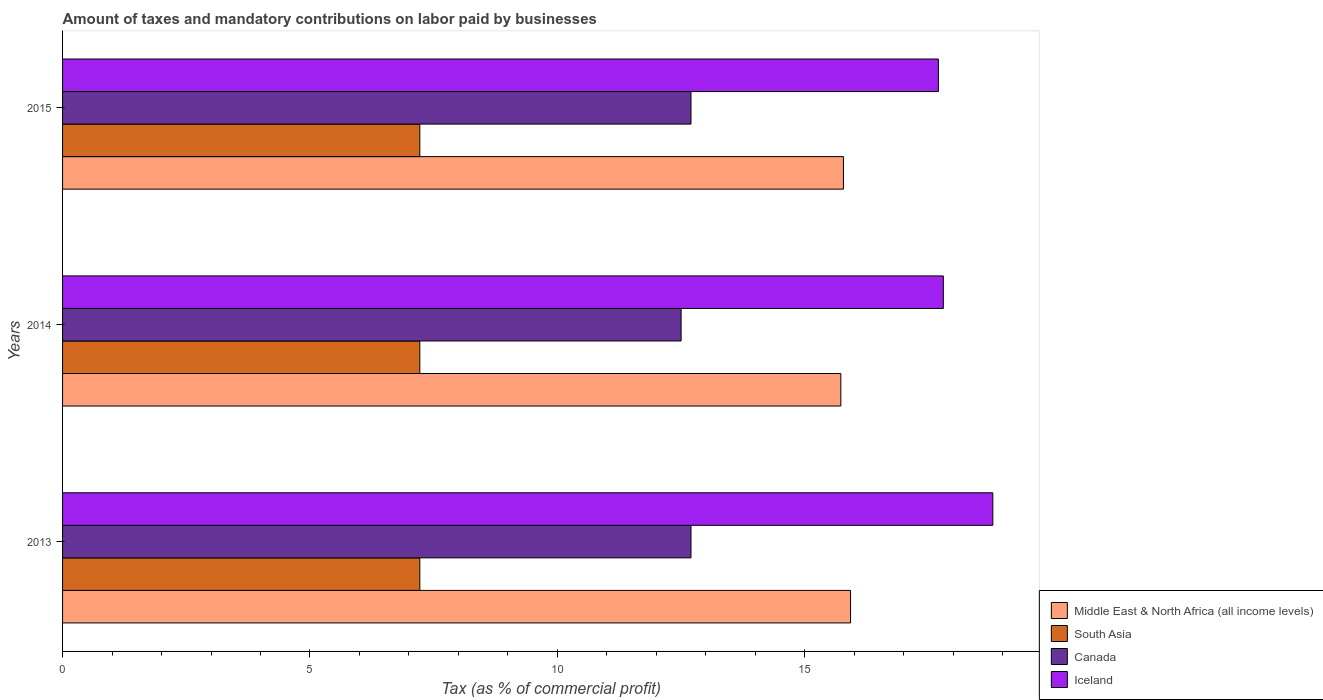How many different coloured bars are there?
Your response must be concise. 4. Are the number of bars per tick equal to the number of legend labels?
Offer a terse response. Yes. Are the number of bars on each tick of the Y-axis equal?
Provide a succinct answer. Yes. How many bars are there on the 3rd tick from the top?
Keep it short and to the point. 4. How many bars are there on the 3rd tick from the bottom?
Keep it short and to the point. 4. What is the label of the 3rd group of bars from the top?
Offer a very short reply. 2013. Across all years, what is the maximum percentage of taxes paid by businesses in Canada?
Offer a terse response. 12.7. In which year was the percentage of taxes paid by businesses in Canada maximum?
Provide a succinct answer. 2013. In which year was the percentage of taxes paid by businesses in South Asia minimum?
Provide a succinct answer. 2013. What is the total percentage of taxes paid by businesses in South Asia in the graph?
Ensure brevity in your answer.  21.66. What is the difference between the percentage of taxes paid by businesses in Iceland in 2013 and that in 2015?
Ensure brevity in your answer.  1.1. What is the difference between the percentage of taxes paid by businesses in Middle East & North Africa (all income levels) in 2014 and the percentage of taxes paid by businesses in Iceland in 2013?
Keep it short and to the point. -3.07. What is the average percentage of taxes paid by businesses in Iceland per year?
Your response must be concise. 18.1. In the year 2013, what is the difference between the percentage of taxes paid by businesses in Middle East & North Africa (all income levels) and percentage of taxes paid by businesses in Iceland?
Offer a terse response. -2.88. In how many years, is the percentage of taxes paid by businesses in Canada greater than 10 %?
Offer a terse response. 3. What is the ratio of the percentage of taxes paid by businesses in South Asia in 2013 to that in 2015?
Make the answer very short. 1. Is the percentage of taxes paid by businesses in Iceland in 2013 less than that in 2015?
Your answer should be very brief. No. What is the difference between the highest and the lowest percentage of taxes paid by businesses in Canada?
Your answer should be compact. 0.2. In how many years, is the percentage of taxes paid by businesses in South Asia greater than the average percentage of taxes paid by businesses in South Asia taken over all years?
Keep it short and to the point. 0. Is the sum of the percentage of taxes paid by businesses in Canada in 2014 and 2015 greater than the maximum percentage of taxes paid by businesses in Middle East & North Africa (all income levels) across all years?
Your answer should be very brief. Yes. What does the 4th bar from the top in 2015 represents?
Provide a short and direct response. Middle East & North Africa (all income levels). What does the 1st bar from the bottom in 2014 represents?
Ensure brevity in your answer.  Middle East & North Africa (all income levels). How many years are there in the graph?
Ensure brevity in your answer.  3. Where does the legend appear in the graph?
Provide a succinct answer. Bottom right. How many legend labels are there?
Your answer should be compact. 4. What is the title of the graph?
Provide a short and direct response. Amount of taxes and mandatory contributions on labor paid by businesses. What is the label or title of the X-axis?
Ensure brevity in your answer.  Tax (as % of commercial profit). What is the Tax (as % of commercial profit) of Middle East & North Africa (all income levels) in 2013?
Provide a succinct answer. 15.93. What is the Tax (as % of commercial profit) of South Asia in 2013?
Make the answer very short. 7.22. What is the Tax (as % of commercial profit) of Middle East & North Africa (all income levels) in 2014?
Keep it short and to the point. 15.73. What is the Tax (as % of commercial profit) of South Asia in 2014?
Provide a succinct answer. 7.22. What is the Tax (as % of commercial profit) of Canada in 2014?
Make the answer very short. 12.5. What is the Tax (as % of commercial profit) in Middle East & North Africa (all income levels) in 2015?
Your answer should be very brief. 15.78. What is the Tax (as % of commercial profit) in South Asia in 2015?
Offer a very short reply. 7.22. What is the Tax (as % of commercial profit) in Canada in 2015?
Keep it short and to the point. 12.7. What is the Tax (as % of commercial profit) in Iceland in 2015?
Your response must be concise. 17.7. Across all years, what is the maximum Tax (as % of commercial profit) of Middle East & North Africa (all income levels)?
Provide a short and direct response. 15.93. Across all years, what is the maximum Tax (as % of commercial profit) in South Asia?
Offer a terse response. 7.22. Across all years, what is the minimum Tax (as % of commercial profit) of Middle East & North Africa (all income levels)?
Give a very brief answer. 15.73. Across all years, what is the minimum Tax (as % of commercial profit) of South Asia?
Your response must be concise. 7.22. Across all years, what is the minimum Tax (as % of commercial profit) in Canada?
Provide a succinct answer. 12.5. Across all years, what is the minimum Tax (as % of commercial profit) of Iceland?
Your answer should be compact. 17.7. What is the total Tax (as % of commercial profit) in Middle East & North Africa (all income levels) in the graph?
Offer a terse response. 47.43. What is the total Tax (as % of commercial profit) of South Asia in the graph?
Offer a very short reply. 21.66. What is the total Tax (as % of commercial profit) of Canada in the graph?
Your answer should be very brief. 37.9. What is the total Tax (as % of commercial profit) of Iceland in the graph?
Your answer should be very brief. 54.3. What is the difference between the Tax (as % of commercial profit) in Middle East & North Africa (all income levels) in 2013 and that in 2014?
Give a very brief answer. 0.2. What is the difference between the Tax (as % of commercial profit) in Middle East & North Africa (all income levels) in 2013 and that in 2015?
Provide a short and direct response. 0.14. What is the difference between the Tax (as % of commercial profit) of Canada in 2013 and that in 2015?
Offer a terse response. 0. What is the difference between the Tax (as % of commercial profit) in Middle East & North Africa (all income levels) in 2014 and that in 2015?
Your response must be concise. -0.05. What is the difference between the Tax (as % of commercial profit) in Canada in 2014 and that in 2015?
Make the answer very short. -0.2. What is the difference between the Tax (as % of commercial profit) of Iceland in 2014 and that in 2015?
Offer a very short reply. 0.1. What is the difference between the Tax (as % of commercial profit) of Middle East & North Africa (all income levels) in 2013 and the Tax (as % of commercial profit) of South Asia in 2014?
Your answer should be very brief. 8.71. What is the difference between the Tax (as % of commercial profit) in Middle East & North Africa (all income levels) in 2013 and the Tax (as % of commercial profit) in Canada in 2014?
Your answer should be very brief. 3.42. What is the difference between the Tax (as % of commercial profit) in Middle East & North Africa (all income levels) in 2013 and the Tax (as % of commercial profit) in Iceland in 2014?
Give a very brief answer. -1.88. What is the difference between the Tax (as % of commercial profit) in South Asia in 2013 and the Tax (as % of commercial profit) in Canada in 2014?
Your answer should be very brief. -5.28. What is the difference between the Tax (as % of commercial profit) in South Asia in 2013 and the Tax (as % of commercial profit) in Iceland in 2014?
Your answer should be very brief. -10.58. What is the difference between the Tax (as % of commercial profit) in Middle East & North Africa (all income levels) in 2013 and the Tax (as % of commercial profit) in South Asia in 2015?
Provide a short and direct response. 8.71. What is the difference between the Tax (as % of commercial profit) in Middle East & North Africa (all income levels) in 2013 and the Tax (as % of commercial profit) in Canada in 2015?
Provide a succinct answer. 3.23. What is the difference between the Tax (as % of commercial profit) of Middle East & North Africa (all income levels) in 2013 and the Tax (as % of commercial profit) of Iceland in 2015?
Make the answer very short. -1.77. What is the difference between the Tax (as % of commercial profit) in South Asia in 2013 and the Tax (as % of commercial profit) in Canada in 2015?
Keep it short and to the point. -5.48. What is the difference between the Tax (as % of commercial profit) in South Asia in 2013 and the Tax (as % of commercial profit) in Iceland in 2015?
Make the answer very short. -10.48. What is the difference between the Tax (as % of commercial profit) of Middle East & North Africa (all income levels) in 2014 and the Tax (as % of commercial profit) of South Asia in 2015?
Offer a terse response. 8.51. What is the difference between the Tax (as % of commercial profit) of Middle East & North Africa (all income levels) in 2014 and the Tax (as % of commercial profit) of Canada in 2015?
Ensure brevity in your answer.  3.03. What is the difference between the Tax (as % of commercial profit) in Middle East & North Africa (all income levels) in 2014 and the Tax (as % of commercial profit) in Iceland in 2015?
Provide a short and direct response. -1.97. What is the difference between the Tax (as % of commercial profit) of South Asia in 2014 and the Tax (as % of commercial profit) of Canada in 2015?
Provide a short and direct response. -5.48. What is the difference between the Tax (as % of commercial profit) of South Asia in 2014 and the Tax (as % of commercial profit) of Iceland in 2015?
Offer a very short reply. -10.48. What is the difference between the Tax (as % of commercial profit) of Canada in 2014 and the Tax (as % of commercial profit) of Iceland in 2015?
Keep it short and to the point. -5.2. What is the average Tax (as % of commercial profit) in Middle East & North Africa (all income levels) per year?
Your answer should be compact. 15.81. What is the average Tax (as % of commercial profit) of South Asia per year?
Give a very brief answer. 7.22. What is the average Tax (as % of commercial profit) in Canada per year?
Ensure brevity in your answer.  12.63. What is the average Tax (as % of commercial profit) of Iceland per year?
Offer a terse response. 18.1. In the year 2013, what is the difference between the Tax (as % of commercial profit) of Middle East & North Africa (all income levels) and Tax (as % of commercial profit) of South Asia?
Keep it short and to the point. 8.71. In the year 2013, what is the difference between the Tax (as % of commercial profit) in Middle East & North Africa (all income levels) and Tax (as % of commercial profit) in Canada?
Offer a very short reply. 3.23. In the year 2013, what is the difference between the Tax (as % of commercial profit) of Middle East & North Africa (all income levels) and Tax (as % of commercial profit) of Iceland?
Make the answer very short. -2.88. In the year 2013, what is the difference between the Tax (as % of commercial profit) in South Asia and Tax (as % of commercial profit) in Canada?
Offer a terse response. -5.48. In the year 2013, what is the difference between the Tax (as % of commercial profit) of South Asia and Tax (as % of commercial profit) of Iceland?
Provide a short and direct response. -11.58. In the year 2013, what is the difference between the Tax (as % of commercial profit) in Canada and Tax (as % of commercial profit) in Iceland?
Offer a terse response. -6.1. In the year 2014, what is the difference between the Tax (as % of commercial profit) of Middle East & North Africa (all income levels) and Tax (as % of commercial profit) of South Asia?
Your answer should be compact. 8.51. In the year 2014, what is the difference between the Tax (as % of commercial profit) of Middle East & North Africa (all income levels) and Tax (as % of commercial profit) of Canada?
Keep it short and to the point. 3.23. In the year 2014, what is the difference between the Tax (as % of commercial profit) in Middle East & North Africa (all income levels) and Tax (as % of commercial profit) in Iceland?
Give a very brief answer. -2.07. In the year 2014, what is the difference between the Tax (as % of commercial profit) of South Asia and Tax (as % of commercial profit) of Canada?
Make the answer very short. -5.28. In the year 2014, what is the difference between the Tax (as % of commercial profit) of South Asia and Tax (as % of commercial profit) of Iceland?
Provide a short and direct response. -10.58. In the year 2014, what is the difference between the Tax (as % of commercial profit) of Canada and Tax (as % of commercial profit) of Iceland?
Your response must be concise. -5.3. In the year 2015, what is the difference between the Tax (as % of commercial profit) of Middle East & North Africa (all income levels) and Tax (as % of commercial profit) of South Asia?
Your response must be concise. 8.56. In the year 2015, what is the difference between the Tax (as % of commercial profit) in Middle East & North Africa (all income levels) and Tax (as % of commercial profit) in Canada?
Your answer should be very brief. 3.08. In the year 2015, what is the difference between the Tax (as % of commercial profit) of Middle East & North Africa (all income levels) and Tax (as % of commercial profit) of Iceland?
Give a very brief answer. -1.92. In the year 2015, what is the difference between the Tax (as % of commercial profit) in South Asia and Tax (as % of commercial profit) in Canada?
Your answer should be very brief. -5.48. In the year 2015, what is the difference between the Tax (as % of commercial profit) in South Asia and Tax (as % of commercial profit) in Iceland?
Your answer should be compact. -10.48. In the year 2015, what is the difference between the Tax (as % of commercial profit) of Canada and Tax (as % of commercial profit) of Iceland?
Provide a succinct answer. -5. What is the ratio of the Tax (as % of commercial profit) of Middle East & North Africa (all income levels) in 2013 to that in 2014?
Offer a terse response. 1.01. What is the ratio of the Tax (as % of commercial profit) in Canada in 2013 to that in 2014?
Your answer should be very brief. 1.02. What is the ratio of the Tax (as % of commercial profit) of Iceland in 2013 to that in 2014?
Ensure brevity in your answer.  1.06. What is the ratio of the Tax (as % of commercial profit) in Middle East & North Africa (all income levels) in 2013 to that in 2015?
Your response must be concise. 1.01. What is the ratio of the Tax (as % of commercial profit) of South Asia in 2013 to that in 2015?
Provide a short and direct response. 1. What is the ratio of the Tax (as % of commercial profit) in Iceland in 2013 to that in 2015?
Provide a succinct answer. 1.06. What is the ratio of the Tax (as % of commercial profit) in Middle East & North Africa (all income levels) in 2014 to that in 2015?
Give a very brief answer. 1. What is the ratio of the Tax (as % of commercial profit) in Canada in 2014 to that in 2015?
Offer a terse response. 0.98. What is the ratio of the Tax (as % of commercial profit) in Iceland in 2014 to that in 2015?
Keep it short and to the point. 1.01. What is the difference between the highest and the second highest Tax (as % of commercial profit) in Middle East & North Africa (all income levels)?
Provide a succinct answer. 0.14. What is the difference between the highest and the second highest Tax (as % of commercial profit) in Canada?
Your response must be concise. 0. What is the difference between the highest and the lowest Tax (as % of commercial profit) in Middle East & North Africa (all income levels)?
Your response must be concise. 0.2. What is the difference between the highest and the lowest Tax (as % of commercial profit) in South Asia?
Offer a very short reply. 0. What is the difference between the highest and the lowest Tax (as % of commercial profit) of Iceland?
Your answer should be very brief. 1.1. 